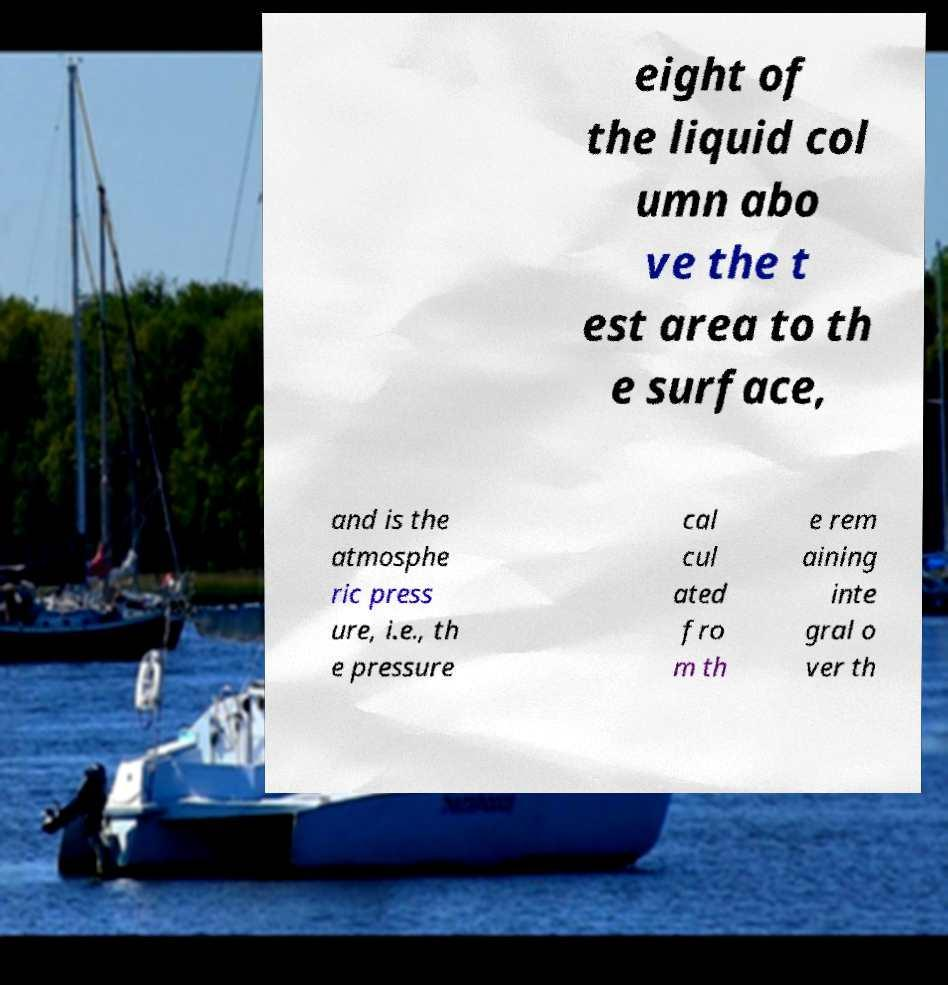Can you read and provide the text displayed in the image?This photo seems to have some interesting text. Can you extract and type it out for me? eight of the liquid col umn abo ve the t est area to th e surface, and is the atmosphe ric press ure, i.e., th e pressure cal cul ated fro m th e rem aining inte gral o ver th 